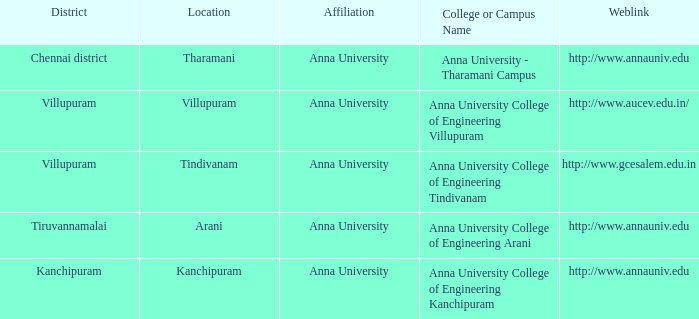What District has a Location of villupuram? Villupuram. 